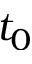<formula> <loc_0><loc_0><loc_500><loc_500>t _ { 0 }</formula> 